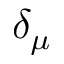<formula> <loc_0><loc_0><loc_500><loc_500>\delta _ { \mu }</formula> 